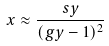Convert formula to latex. <formula><loc_0><loc_0><loc_500><loc_500>x \approx \frac { s y } { ( g y - 1 ) ^ { 2 } }</formula> 